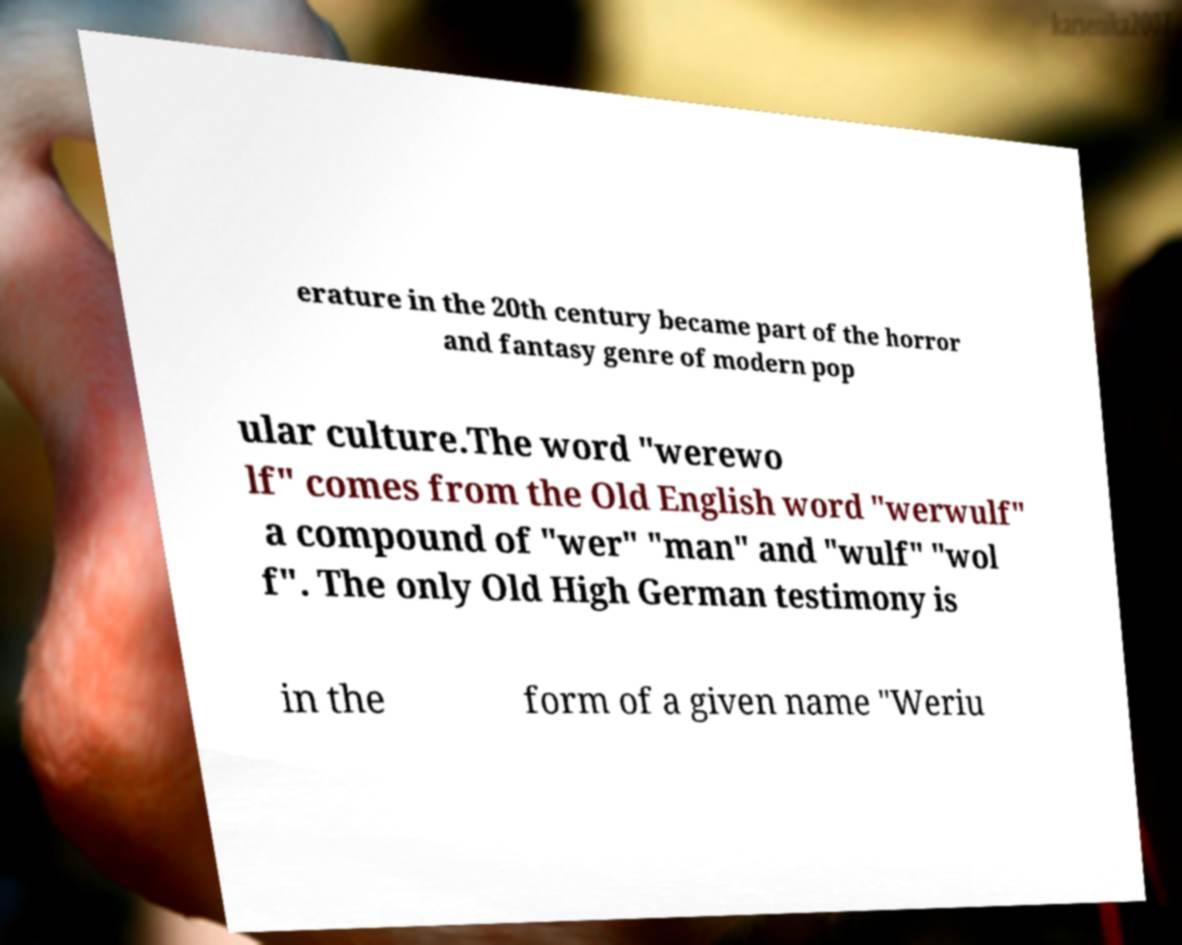There's text embedded in this image that I need extracted. Can you transcribe it verbatim? erature in the 20th century became part of the horror and fantasy genre of modern pop ular culture.The word "werewo lf" comes from the Old English word "werwulf" a compound of "wer" "man" and "wulf" "wol f". The only Old High German testimony is in the form of a given name "Weriu 